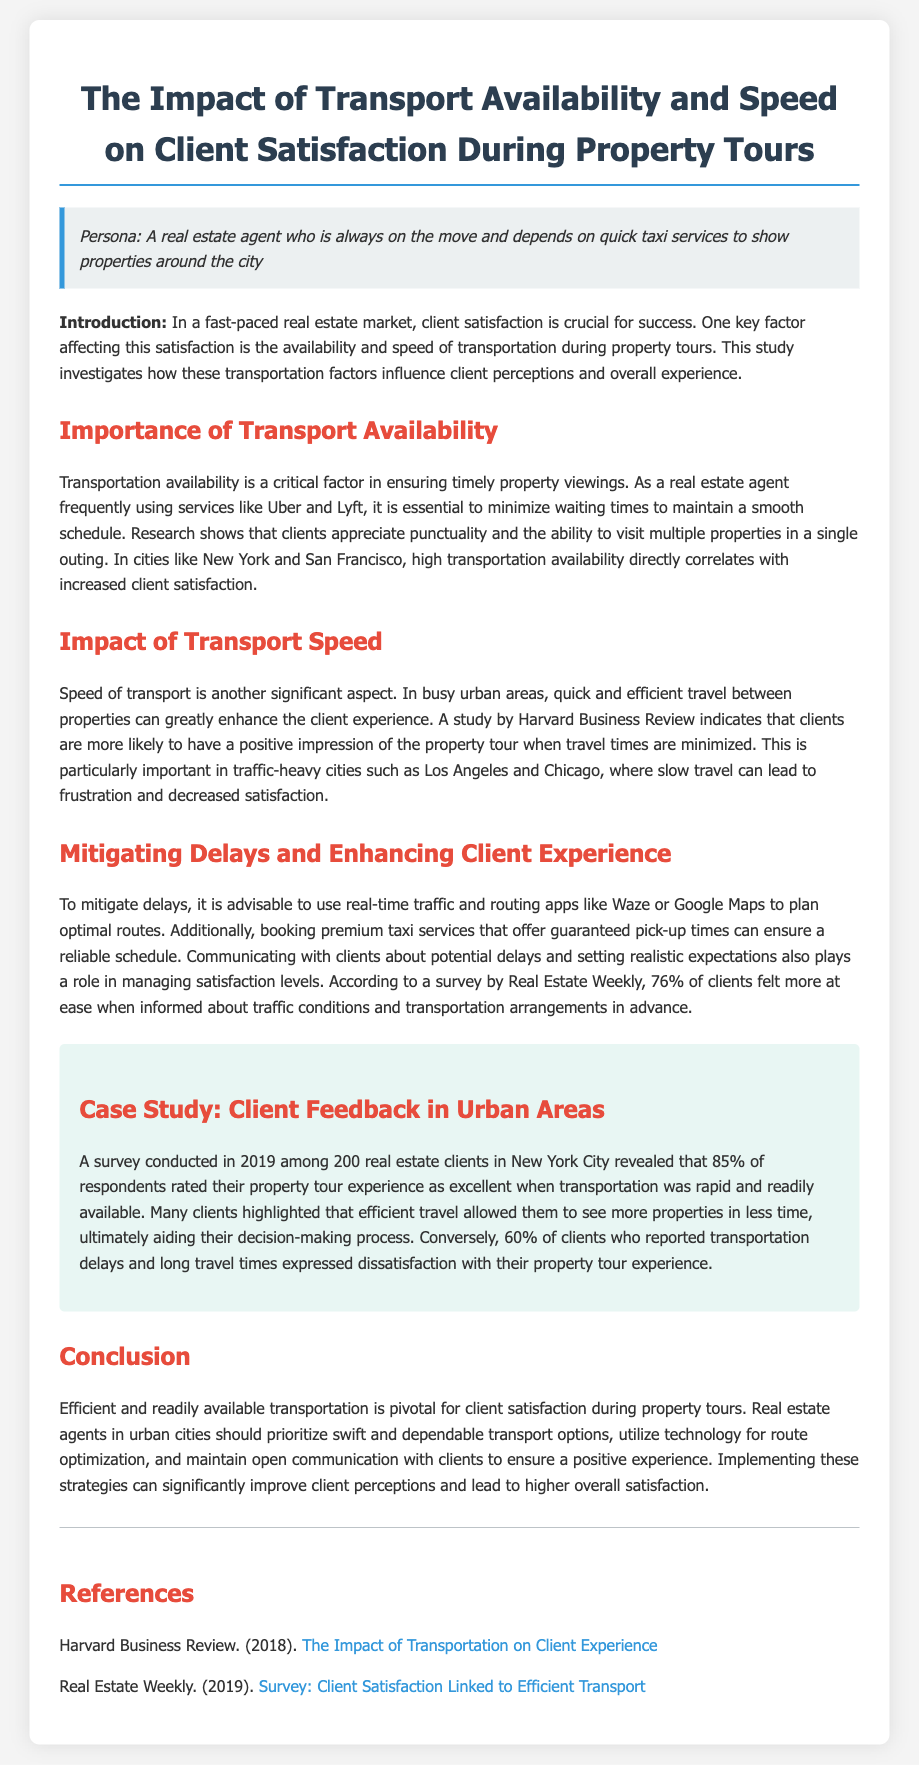What is the main focus of the study? The study investigates how transportation factors influence client perceptions and overall experience during property tours.
Answer: Transportation factors What percentage of clients rated their experience as excellent when transportation was rapid? According to the survey results in the case study, 85% of respondents rated their experience as excellent when transportation was rapid and readily available.
Answer: 85% Which cities are mentioned as having a direct correlation between transport availability and client satisfaction? The document mentions New York and San Francisco as cities where high transportation availability correlates with increased client satisfaction.
Answer: New York and San Francisco What technology is recommended to mitigate delays? The document suggests using real-time traffic and routing apps like Waze or Google Maps to plan optimal routes and mitigate delays.
Answer: Waze or Google Maps What is the main conclusion drawn in the document? The conclusion emphasizes that efficient and readily available transportation is pivotal for client satisfaction during property tours.
Answer: Efficient and readily available transportation What year was the client feedback survey conducted in New York City? The survey mentioned in the document was conducted in 2019.
Answer: 2019 What is the percentage of clients who expressed dissatisfaction due to delays? The document states that 60% of clients who reported transportation delays and long travel times expressed dissatisfaction with their experience.
Answer: 60% What is the source of the statistics regarding client satisfaction and transport? The statistics regarding client satisfaction related to transportation come from the Real Estate Weekly survey mentioned in the references.
Answer: Real Estate Weekly 